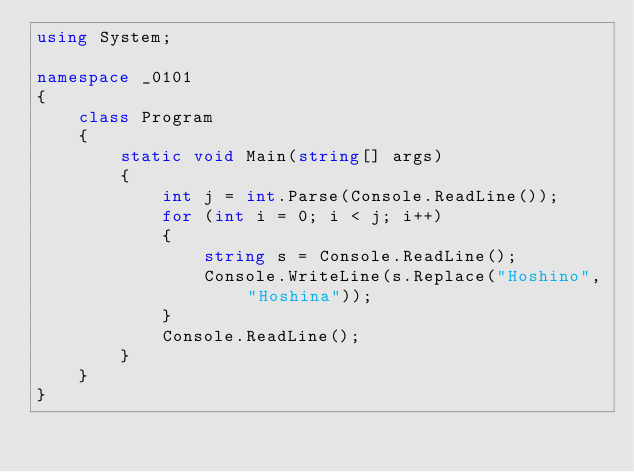Convert code to text. <code><loc_0><loc_0><loc_500><loc_500><_C#_>using System;

namespace _0101
{
    class Program
    {
        static void Main(string[] args)
        {
            int j = int.Parse(Console.ReadLine());
            for (int i = 0; i < j; i++)
            {
                string s = Console.ReadLine();
                Console.WriteLine(s.Replace("Hoshino", "Hoshina"));
            }
            Console.ReadLine();
        }
    }
}</code> 